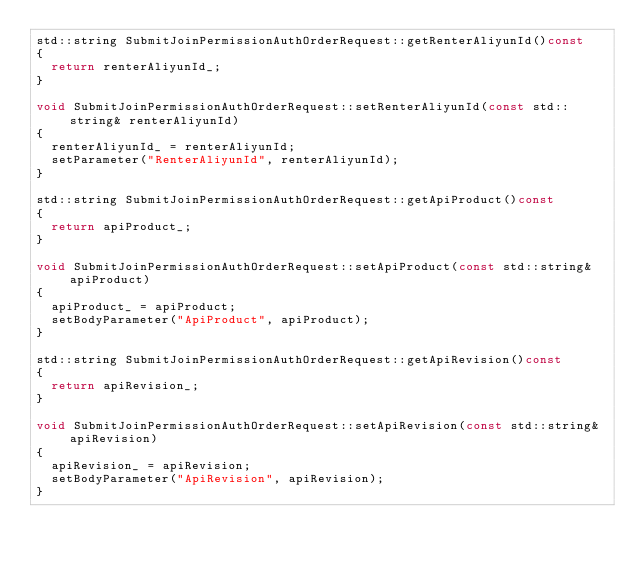Convert code to text. <code><loc_0><loc_0><loc_500><loc_500><_C++_>std::string SubmitJoinPermissionAuthOrderRequest::getRenterAliyunId()const
{
	return renterAliyunId_;
}

void SubmitJoinPermissionAuthOrderRequest::setRenterAliyunId(const std::string& renterAliyunId)
{
	renterAliyunId_ = renterAliyunId;
	setParameter("RenterAliyunId", renterAliyunId);
}

std::string SubmitJoinPermissionAuthOrderRequest::getApiProduct()const
{
	return apiProduct_;
}

void SubmitJoinPermissionAuthOrderRequest::setApiProduct(const std::string& apiProduct)
{
	apiProduct_ = apiProduct;
	setBodyParameter("ApiProduct", apiProduct);
}

std::string SubmitJoinPermissionAuthOrderRequest::getApiRevision()const
{
	return apiRevision_;
}

void SubmitJoinPermissionAuthOrderRequest::setApiRevision(const std::string& apiRevision)
{
	apiRevision_ = apiRevision;
	setBodyParameter("ApiRevision", apiRevision);
}

</code> 